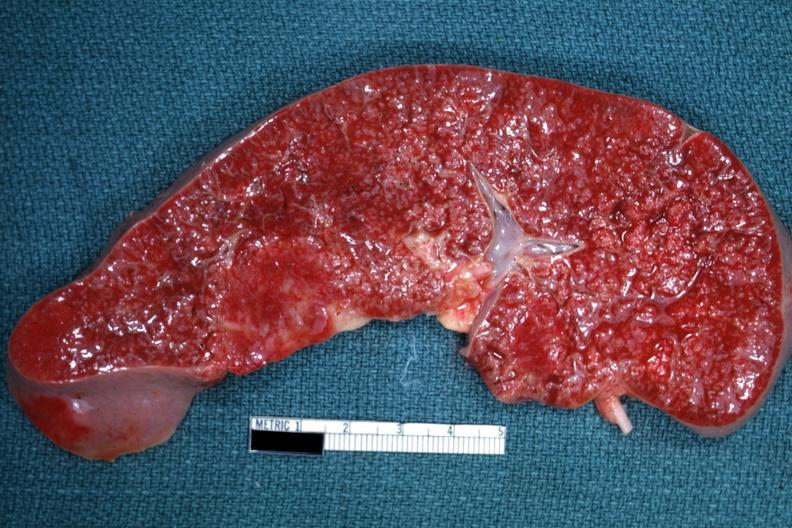what diagnosed as reticulum cell sarcoma?
Answer the question using a single word or phrase. Granulomata 